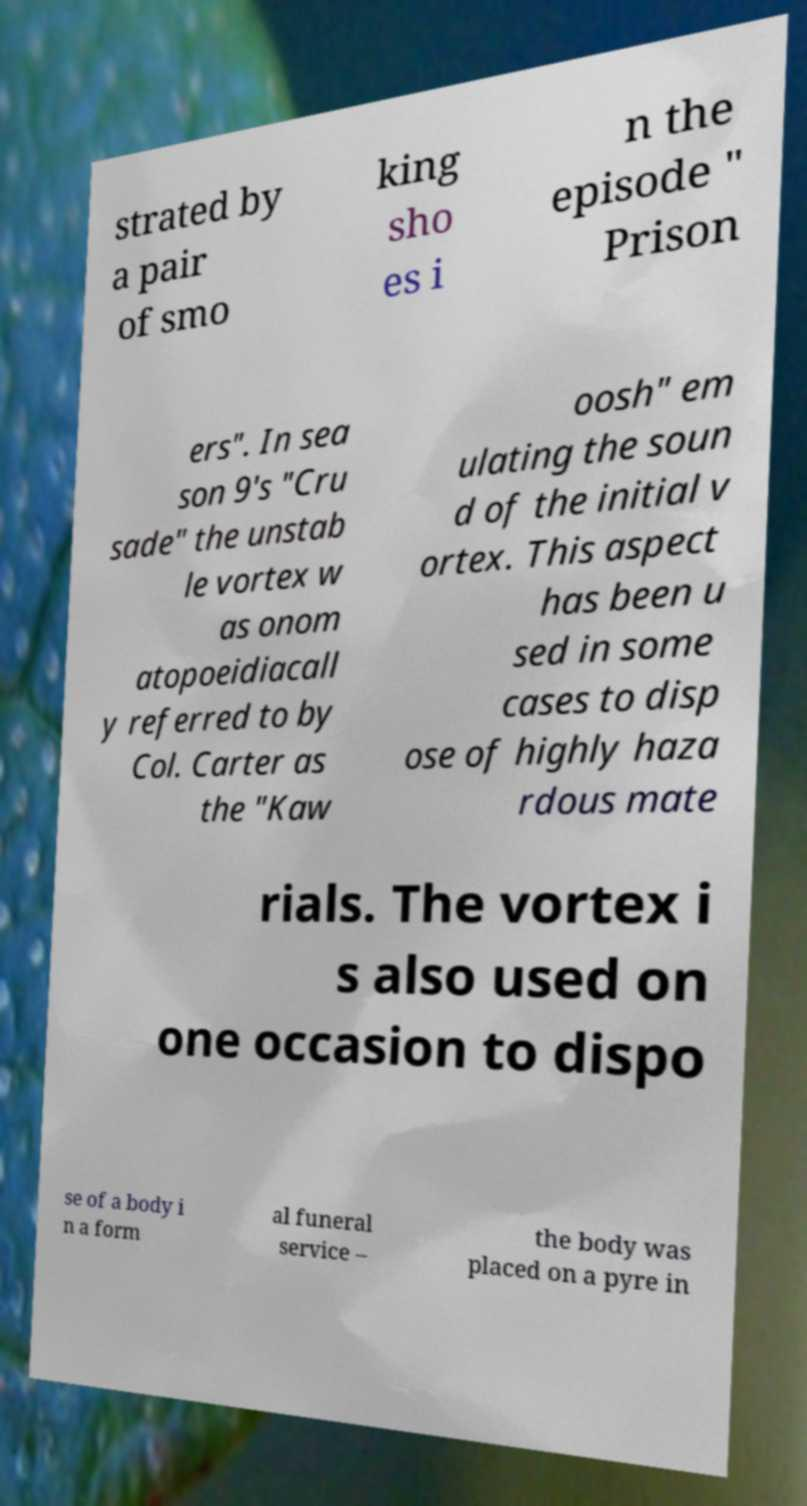Can you read and provide the text displayed in the image?This photo seems to have some interesting text. Can you extract and type it out for me? strated by a pair of smo king sho es i n the episode " Prison ers". In sea son 9's "Cru sade" the unstab le vortex w as onom atopoeidiacall y referred to by Col. Carter as the "Kaw oosh" em ulating the soun d of the initial v ortex. This aspect has been u sed in some cases to disp ose of highly haza rdous mate rials. The vortex i s also used on one occasion to dispo se of a body i n a form al funeral service – the body was placed on a pyre in 